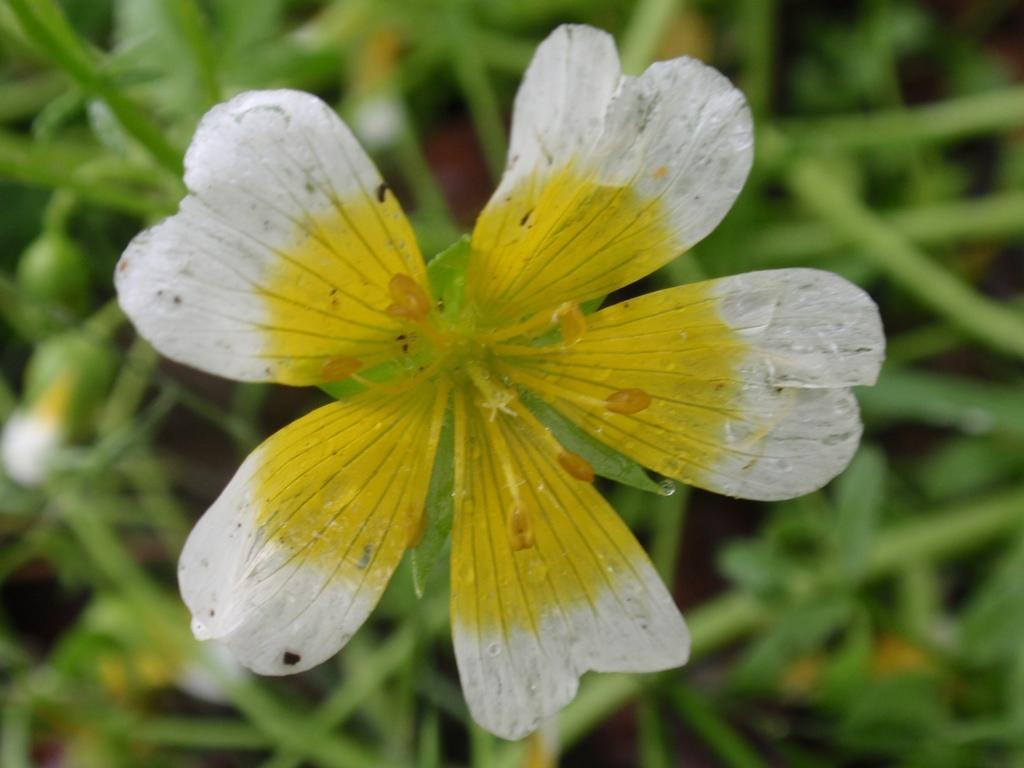How would you summarize this image in a sentence or two? In the center of the image we can see a flower. On the left side of the image we can see the buds. In the background of the image we can see the leaves. 